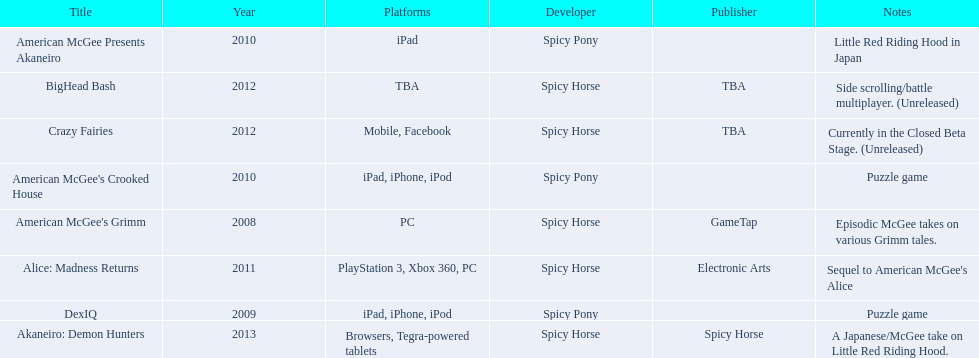What are all of the game titles? American McGee's Grimm, DexIQ, American McGee Presents Akaneiro, American McGee's Crooked House, Alice: Madness Returns, BigHead Bash, Crazy Fairies, Akaneiro: Demon Hunters. Which developer developed a game in 2011? Spicy Horse. Who published this game in 2011 Electronic Arts. What was the name of this published game in 2011? Alice: Madness Returns. 